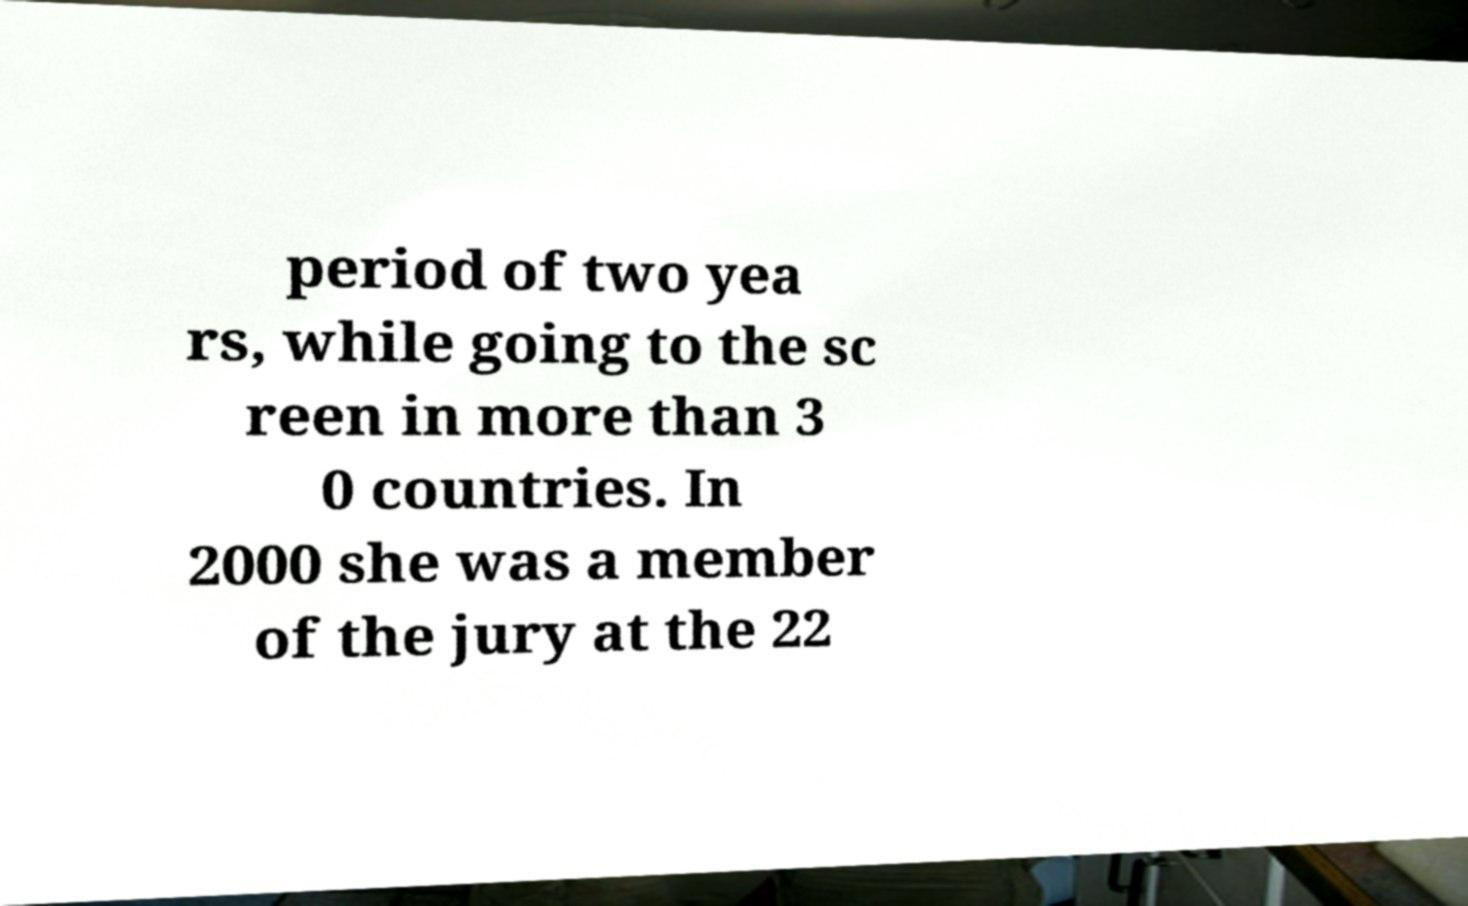What messages or text are displayed in this image? I need them in a readable, typed format. period of two yea rs, while going to the sc reen in more than 3 0 countries. In 2000 she was a member of the jury at the 22 